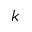Convert formula to latex. <formula><loc_0><loc_0><loc_500><loc_500>k</formula> 